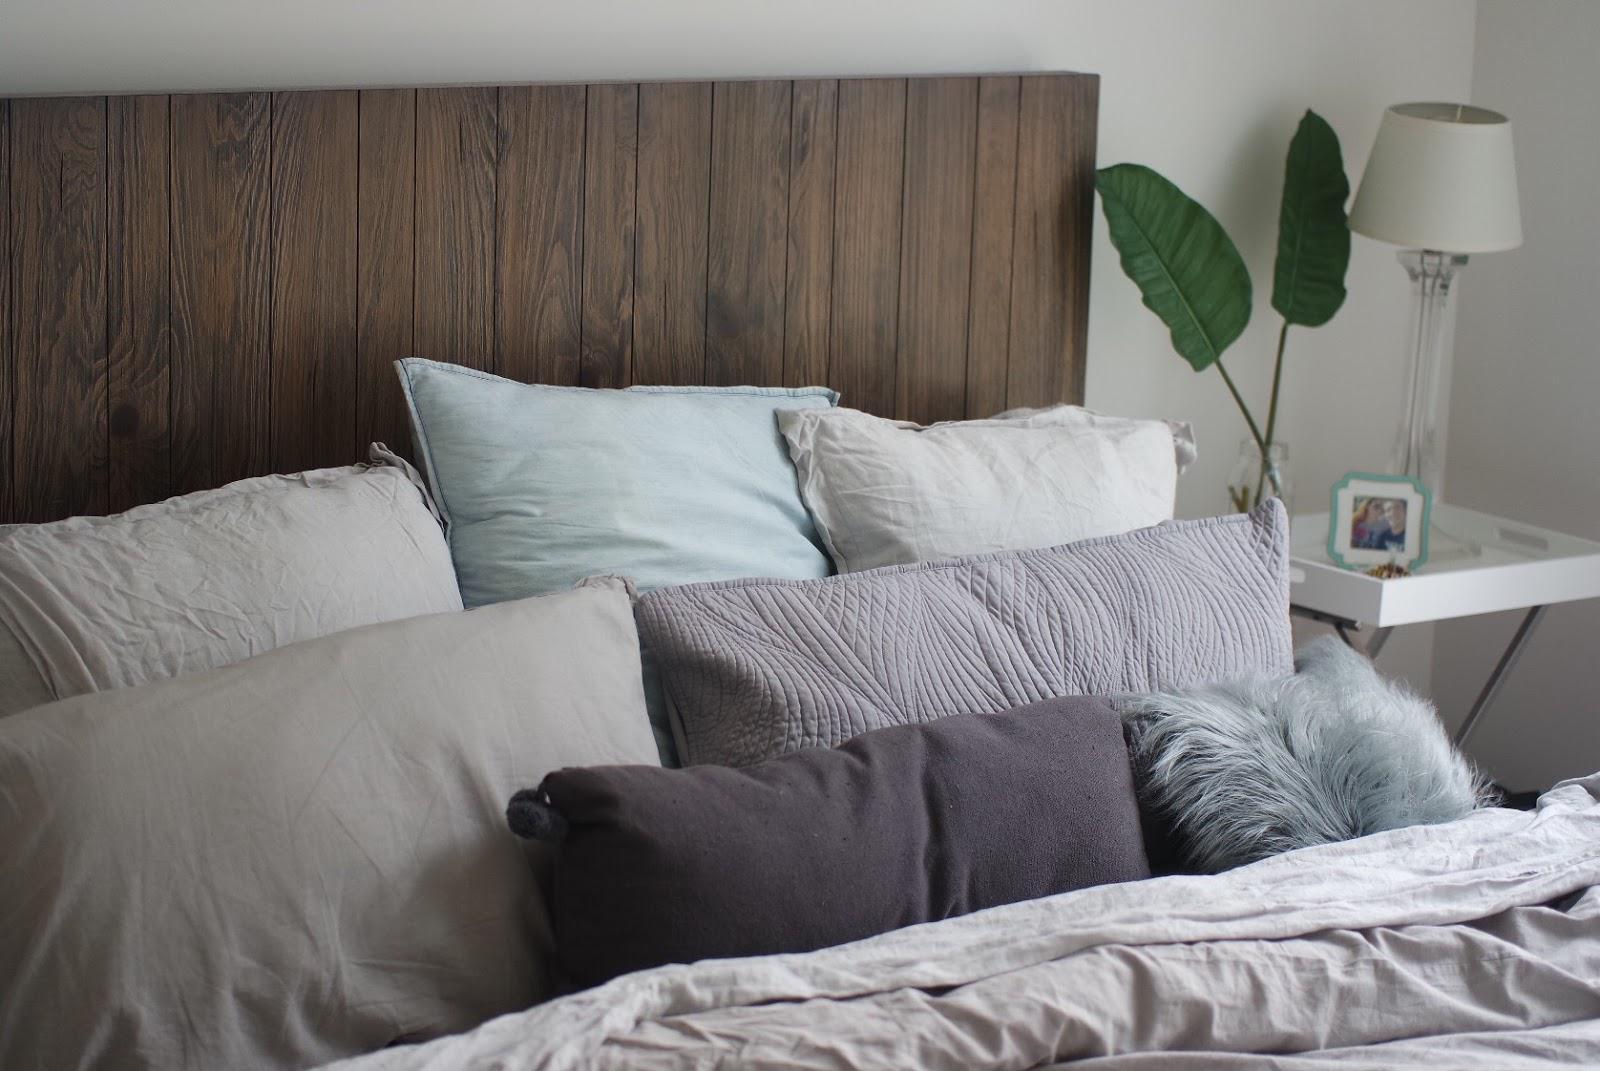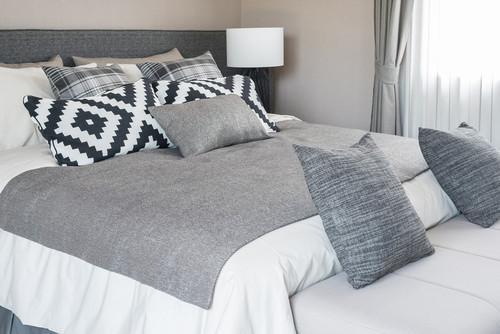The first image is the image on the left, the second image is the image on the right. Evaluate the accuracy of this statement regarding the images: "The bed on the farthest right has mostly solid white pillows.". Is it true? Answer yes or no. No. 